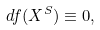<formula> <loc_0><loc_0><loc_500><loc_500>d f ( X ^ { S } ) \equiv 0 ,</formula> 